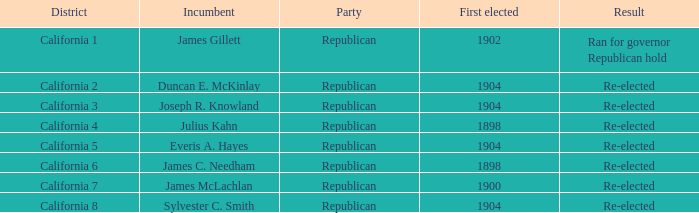In the 5th district of california, what is the highest first-time election result that resulted in a re-election? 1904.0. 